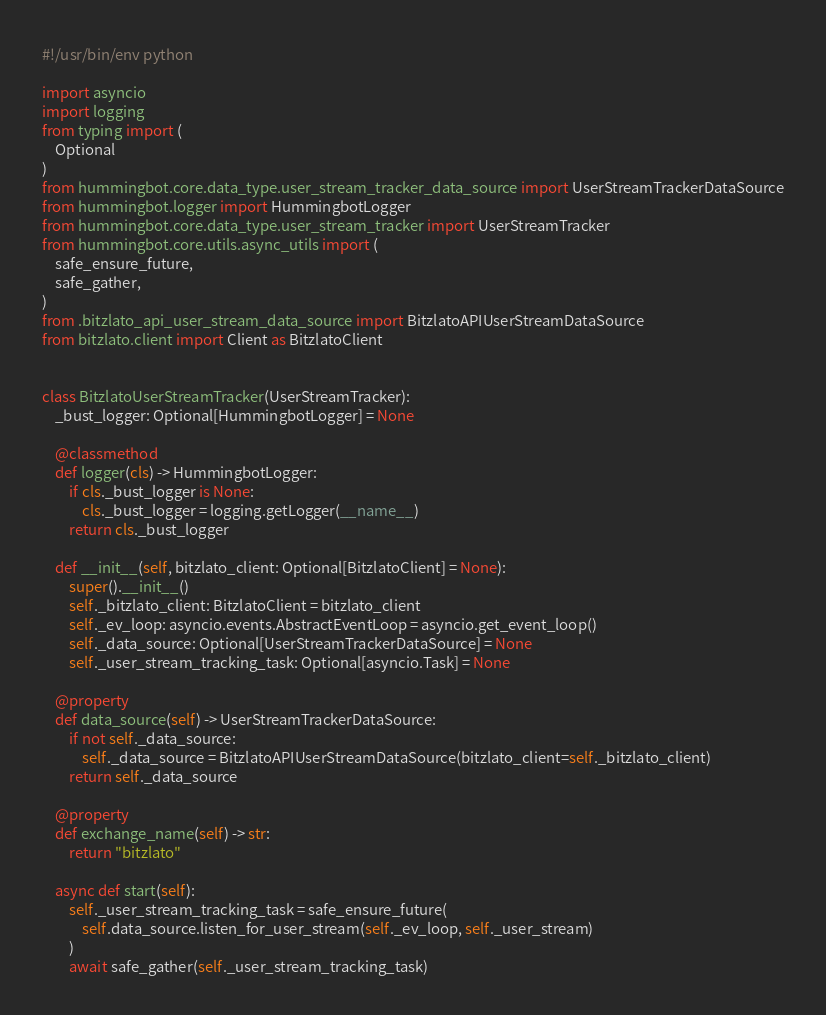Convert code to text. <code><loc_0><loc_0><loc_500><loc_500><_Python_>#!/usr/bin/env python

import asyncio
import logging
from typing import (
    Optional
)
from hummingbot.core.data_type.user_stream_tracker_data_source import UserStreamTrackerDataSource
from hummingbot.logger import HummingbotLogger
from hummingbot.core.data_type.user_stream_tracker import UserStreamTracker
from hummingbot.core.utils.async_utils import (
    safe_ensure_future,
    safe_gather,
)
from .bitzlato_api_user_stream_data_source import BitzlatoAPIUserStreamDataSource
from bitzlato.client import Client as BitzlatoClient


class BitzlatoUserStreamTracker(UserStreamTracker):
    _bust_logger: Optional[HummingbotLogger] = None

    @classmethod
    def logger(cls) -> HummingbotLogger:
        if cls._bust_logger is None:
            cls._bust_logger = logging.getLogger(__name__)
        return cls._bust_logger

    def __init__(self, bitzlato_client: Optional[BitzlatoClient] = None):
        super().__init__()
        self._bitzlato_client: BitzlatoClient = bitzlato_client
        self._ev_loop: asyncio.events.AbstractEventLoop = asyncio.get_event_loop()
        self._data_source: Optional[UserStreamTrackerDataSource] = None
        self._user_stream_tracking_task: Optional[asyncio.Task] = None

    @property
    def data_source(self) -> UserStreamTrackerDataSource:
        if not self._data_source:
            self._data_source = BitzlatoAPIUserStreamDataSource(bitzlato_client=self._bitzlato_client)
        return self._data_source

    @property
    def exchange_name(self) -> str:
        return "bitzlato"

    async def start(self):
        self._user_stream_tracking_task = safe_ensure_future(
            self.data_source.listen_for_user_stream(self._ev_loop, self._user_stream)
        )
        await safe_gather(self._user_stream_tracking_task)
</code> 